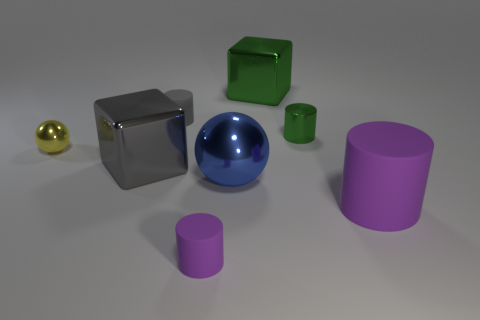There is a green metal thing that is behind the tiny matte cylinder behind the blue sphere; what shape is it?
Offer a terse response. Cube. Are there any small cyan cubes made of the same material as the small ball?
Keep it short and to the point. No. Is the size of the sphere that is in front of the gray cube the same as the big green metal thing?
Provide a succinct answer. Yes. How many red objects are either metallic things or large cylinders?
Ensure brevity in your answer.  0. There is a block behind the small yellow object; what is it made of?
Offer a very short reply. Metal. There is a gray cylinder behind the large blue shiny thing; how many large blue metal balls are right of it?
Provide a succinct answer. 1. How many small green things have the same shape as the large purple matte thing?
Your answer should be compact. 1. How many big rubber cylinders are there?
Your response must be concise. 1. There is a shiny object in front of the big gray block; what color is it?
Make the answer very short. Blue. There is a shiny ball that is to the left of the small rubber object in front of the large gray cube; what is its color?
Your answer should be very brief. Yellow. 